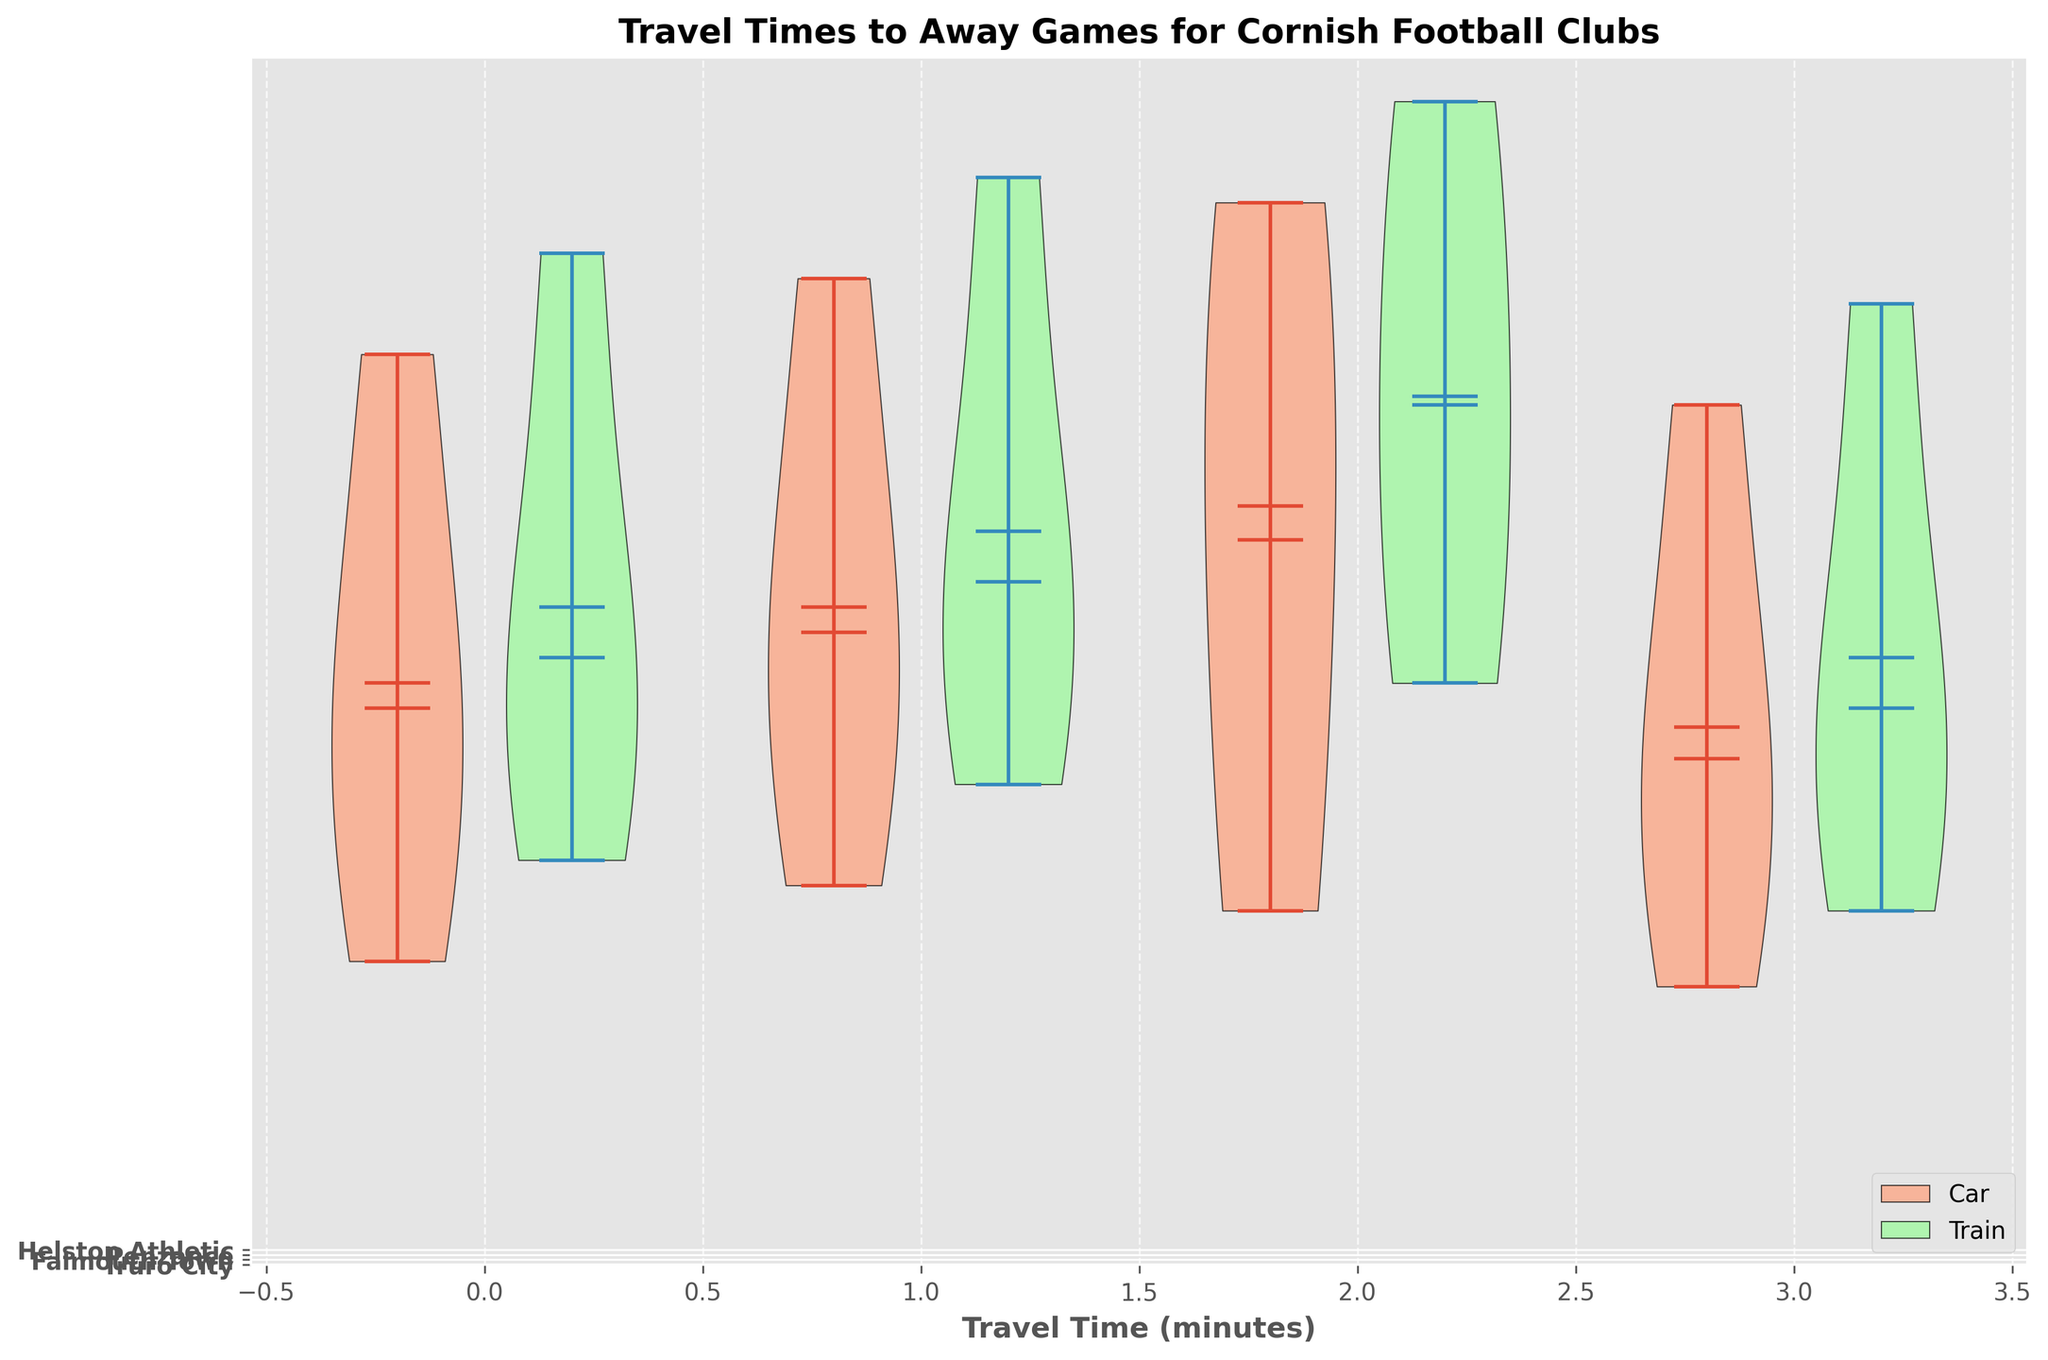What is the title of the figure? The title is located at the top of the figure and usually provides an overview of the data being presented.
Answer: Travel Times to Away Games for Cornish Football Clubs What modes of travel are represented in the legend? The legend of the figure, usually located at a corner, shows color-coded rectangles representing different modes of travel.
Answer: Car and Train Which club has the widest range of travel times for car travel? By comparing the width of the violin plots for car travel, you can identify the club with the greatest spread in travel times.
Answer: Penzance What is the combined average travel time for Truro City to all destinations by car? Calculate the average of car travel times for Truro City by adding all travel times and dividing by the number of destinations: (60 + 100 + 120 + 180) / 4 = 115.
Answer: 115 minutes What is the difference between the median travel times by train for Truro City and Helston Athletic? Find the median travel times for both clubs from the violin plots, then compute the difference: for example, if Truro City's median by train is ~120 and Helston Athletic's median is ~95, then 120 - 95 = 25.
Answer: 25 minutes (hypothetical median values for the explanation) Which mode of travel generally shows higher travel times for Truro City? Compare the positions of the violin plots for both car and train travel times for Truro City to see which is consistently higher.
Answer: Train Which club has the least travel time to Plymouth by car? Look at the lowest points of the violin plots for each club traveling to Plymouth by car to determine the minimum value.
Answer: Helston Athletic What is the approximate median travel time by train for Falmouth Town? Locate the horizontal line inside the violin plot for Falmouth Town in the train section, which represents the median value.
Answer: ~170 minutes Which club has the most similar travel times by car and by train for travel to Bath? Compare the overlap or closeness of the violin plots for each club traveling to Bath by car and train to identify the club with the most similar travel times.
Answer: Helston Athletic (hypothetical closeness for the explanation) 